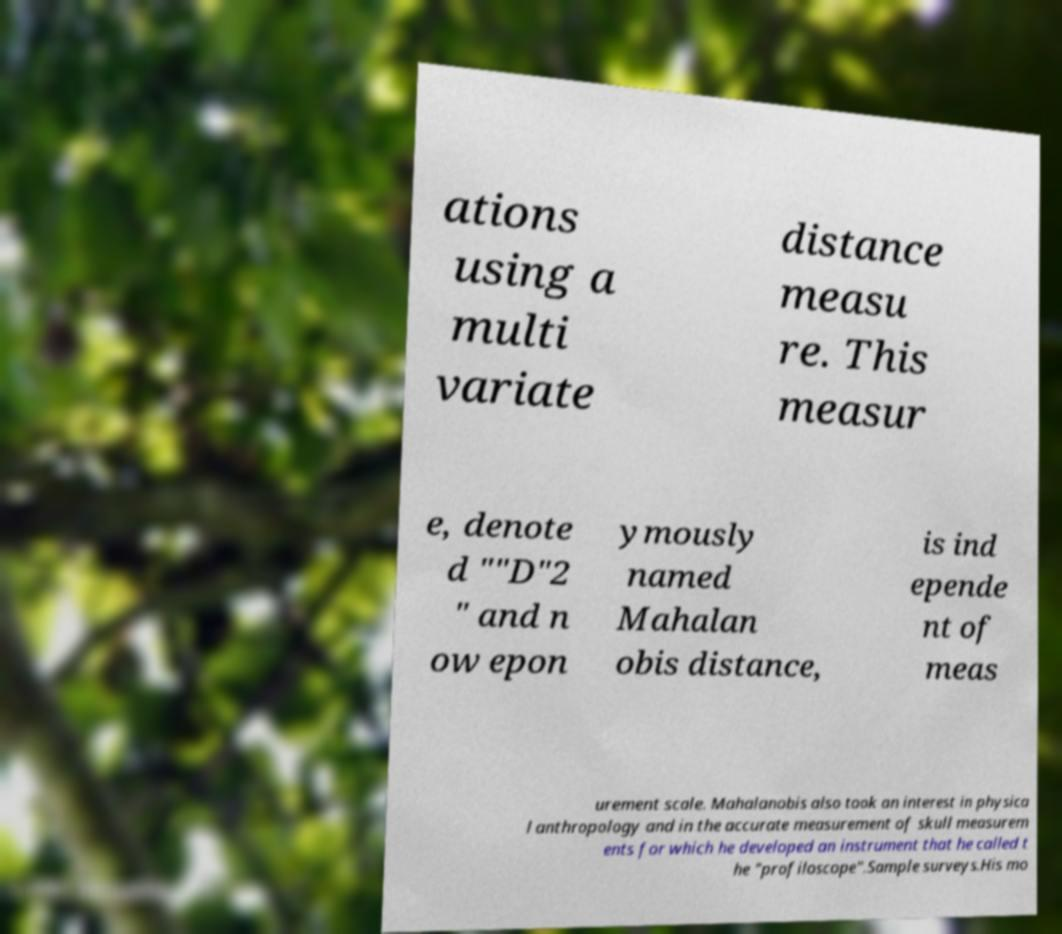Could you assist in decoding the text presented in this image and type it out clearly? ations using a multi variate distance measu re. This measur e, denote d ""D"2 " and n ow epon ymously named Mahalan obis distance, is ind epende nt of meas urement scale. Mahalanobis also took an interest in physica l anthropology and in the accurate measurement of skull measurem ents for which he developed an instrument that he called t he "profiloscope".Sample surveys.His mo 